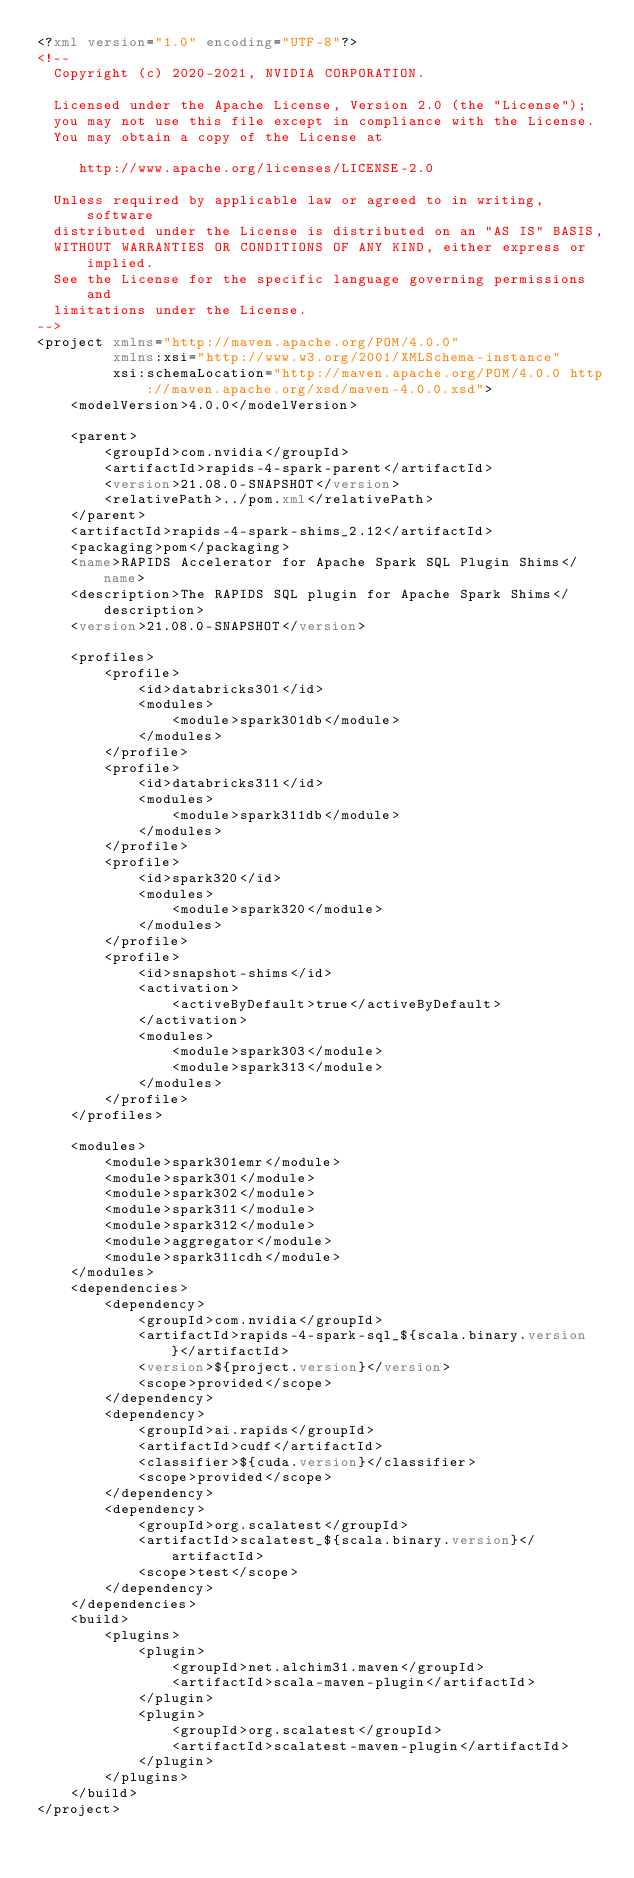Convert code to text. <code><loc_0><loc_0><loc_500><loc_500><_XML_><?xml version="1.0" encoding="UTF-8"?>
<!--
  Copyright (c) 2020-2021, NVIDIA CORPORATION.

  Licensed under the Apache License, Version 2.0 (the "License");
  you may not use this file except in compliance with the License.
  You may obtain a copy of the License at

     http://www.apache.org/licenses/LICENSE-2.0

  Unless required by applicable law or agreed to in writing, software
  distributed under the License is distributed on an "AS IS" BASIS,
  WITHOUT WARRANTIES OR CONDITIONS OF ANY KIND, either express or implied.
  See the License for the specific language governing permissions and
  limitations under the License.
-->
<project xmlns="http://maven.apache.org/POM/4.0.0"
         xmlns:xsi="http://www.w3.org/2001/XMLSchema-instance"
         xsi:schemaLocation="http://maven.apache.org/POM/4.0.0 http://maven.apache.org/xsd/maven-4.0.0.xsd">
    <modelVersion>4.0.0</modelVersion>

    <parent>
        <groupId>com.nvidia</groupId>
        <artifactId>rapids-4-spark-parent</artifactId>
        <version>21.08.0-SNAPSHOT</version>
        <relativePath>../pom.xml</relativePath>
    </parent>
    <artifactId>rapids-4-spark-shims_2.12</artifactId>
    <packaging>pom</packaging>
    <name>RAPIDS Accelerator for Apache Spark SQL Plugin Shims</name>
    <description>The RAPIDS SQL plugin for Apache Spark Shims</description>
    <version>21.08.0-SNAPSHOT</version>

    <profiles>
        <profile>
            <id>databricks301</id>
            <modules>
                <module>spark301db</module>
            </modules>
        </profile>
        <profile>
            <id>databricks311</id>
            <modules>
                <module>spark311db</module>
            </modules>
        </profile>
        <profile>
            <id>spark320</id>
            <modules>
                <module>spark320</module>
            </modules>
        </profile>
        <profile>
            <id>snapshot-shims</id>
            <activation>
                <activeByDefault>true</activeByDefault>
            </activation>
            <modules>
                <module>spark303</module>
                <module>spark313</module>
            </modules>
        </profile>
    </profiles>

    <modules>
        <module>spark301emr</module>
        <module>spark301</module>
        <module>spark302</module>
        <module>spark311</module>
        <module>spark312</module>
        <module>aggregator</module>
        <module>spark311cdh</module>
    </modules>
    <dependencies>
        <dependency>
            <groupId>com.nvidia</groupId>
            <artifactId>rapids-4-spark-sql_${scala.binary.version}</artifactId>
            <version>${project.version}</version>
            <scope>provided</scope>
        </dependency>
        <dependency>
            <groupId>ai.rapids</groupId>
            <artifactId>cudf</artifactId>
            <classifier>${cuda.version}</classifier>
            <scope>provided</scope>
        </dependency>
        <dependency>
            <groupId>org.scalatest</groupId>
            <artifactId>scalatest_${scala.binary.version}</artifactId>
            <scope>test</scope>
        </dependency>
    </dependencies>
    <build>
        <plugins>
            <plugin>
                <groupId>net.alchim31.maven</groupId>
                <artifactId>scala-maven-plugin</artifactId>
            </plugin>
            <plugin>
                <groupId>org.scalatest</groupId>
                <artifactId>scalatest-maven-plugin</artifactId>
            </plugin>
        </plugins>
    </build>
</project>
</code> 